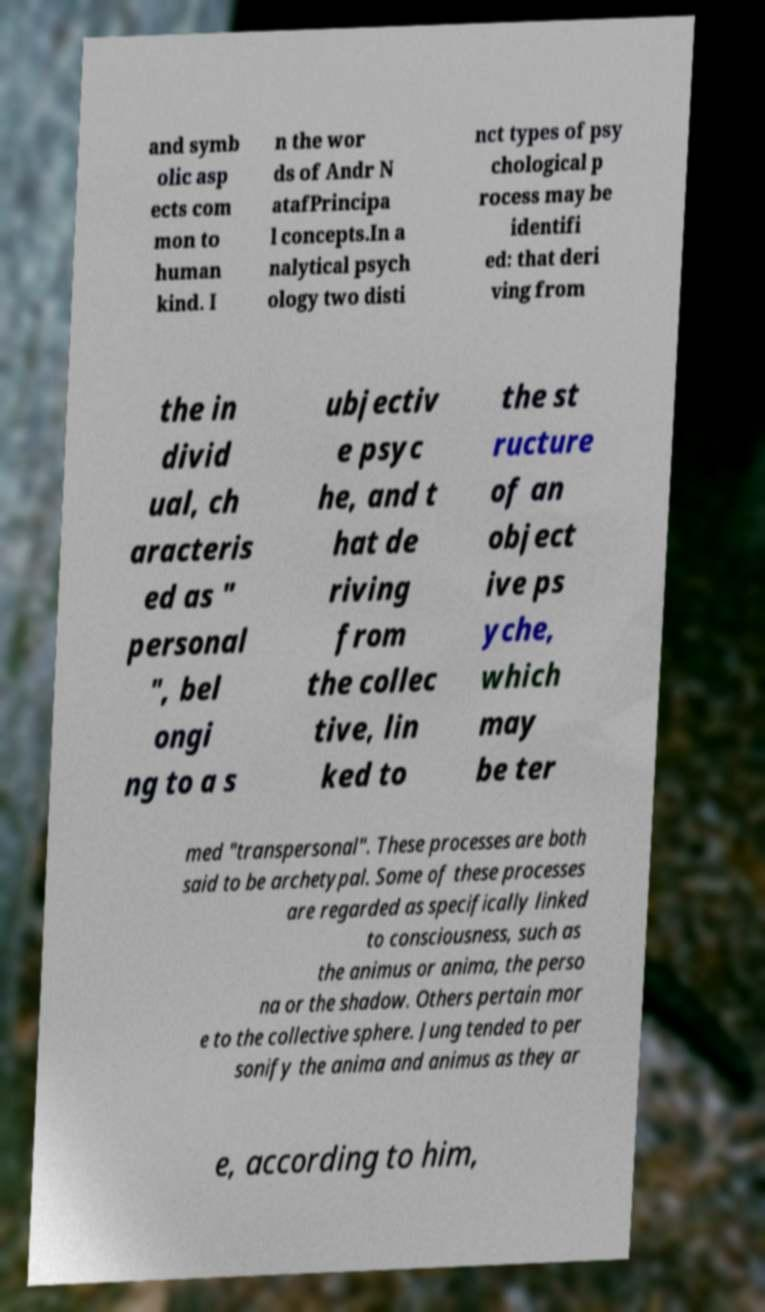Could you assist in decoding the text presented in this image and type it out clearly? and symb olic asp ects com mon to human kind. I n the wor ds of Andr N atafPrincipa l concepts.In a nalytical psych ology two disti nct types of psy chological p rocess may be identifi ed: that deri ving from the in divid ual, ch aracteris ed as " personal ", bel ongi ng to a s ubjectiv e psyc he, and t hat de riving from the collec tive, lin ked to the st ructure of an object ive ps yche, which may be ter med "transpersonal". These processes are both said to be archetypal. Some of these processes are regarded as specifically linked to consciousness, such as the animus or anima, the perso na or the shadow. Others pertain mor e to the collective sphere. Jung tended to per sonify the anima and animus as they ar e, according to him, 